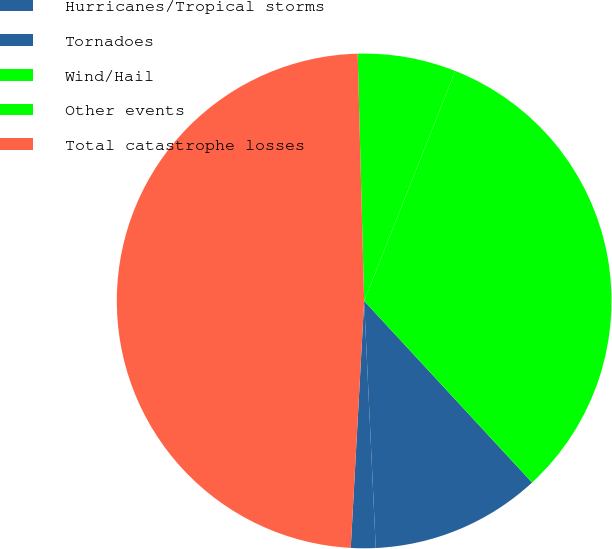Convert chart to OTSL. <chart><loc_0><loc_0><loc_500><loc_500><pie_chart><fcel>Hurricanes/Tropical storms<fcel>Tornadoes<fcel>Wind/Hail<fcel>Other events<fcel>Total catastrophe losses<nl><fcel>1.61%<fcel>11.13%<fcel>32.12%<fcel>6.42%<fcel>48.72%<nl></chart> 